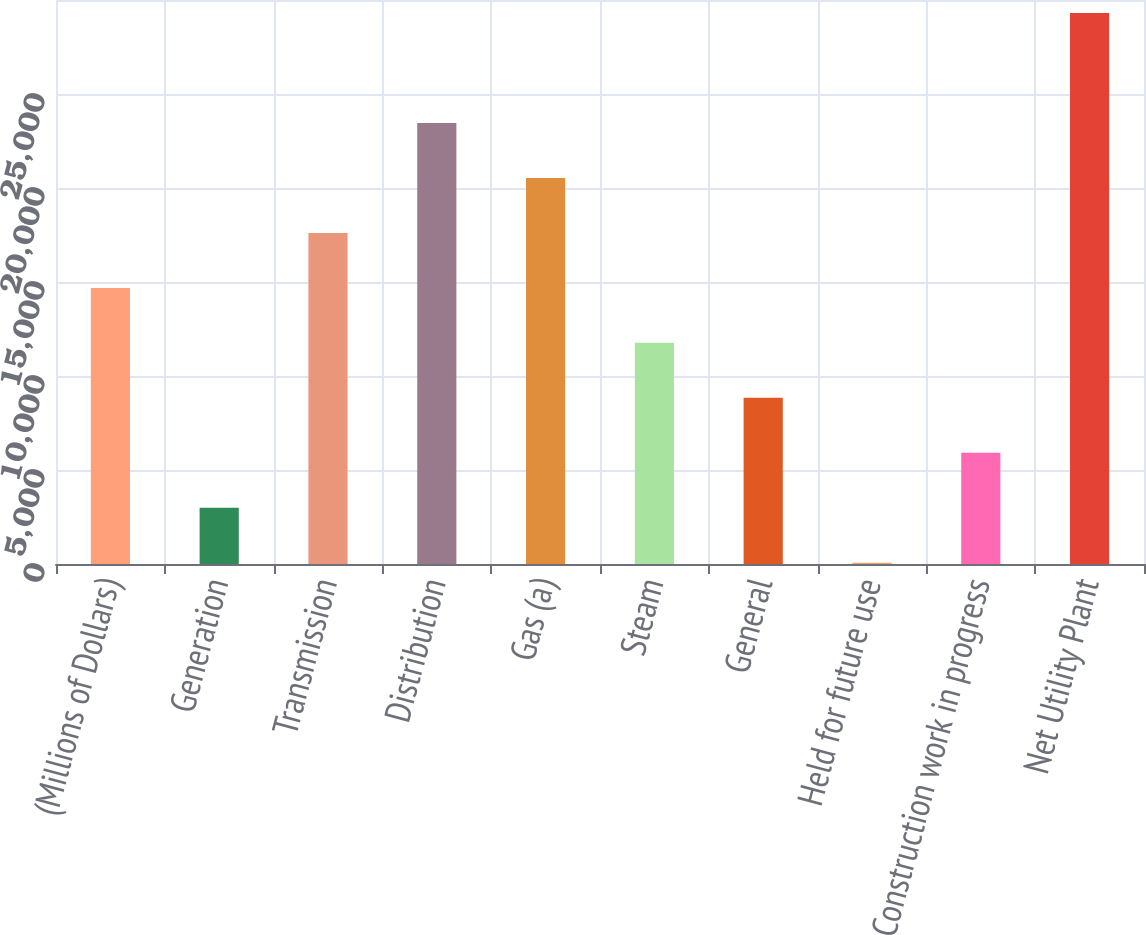Convert chart. <chart><loc_0><loc_0><loc_500><loc_500><bar_chart><fcel>(Millions of Dollars)<fcel>Generation<fcel>Transmission<fcel>Distribution<fcel>Gas (a)<fcel>Steam<fcel>General<fcel>Held for future use<fcel>Construction work in progress<fcel>Net Utility Plant<nl><fcel>14687.5<fcel>2989.5<fcel>17612<fcel>23461<fcel>20536.5<fcel>11763<fcel>8838.5<fcel>65<fcel>5914<fcel>29310<nl></chart> 